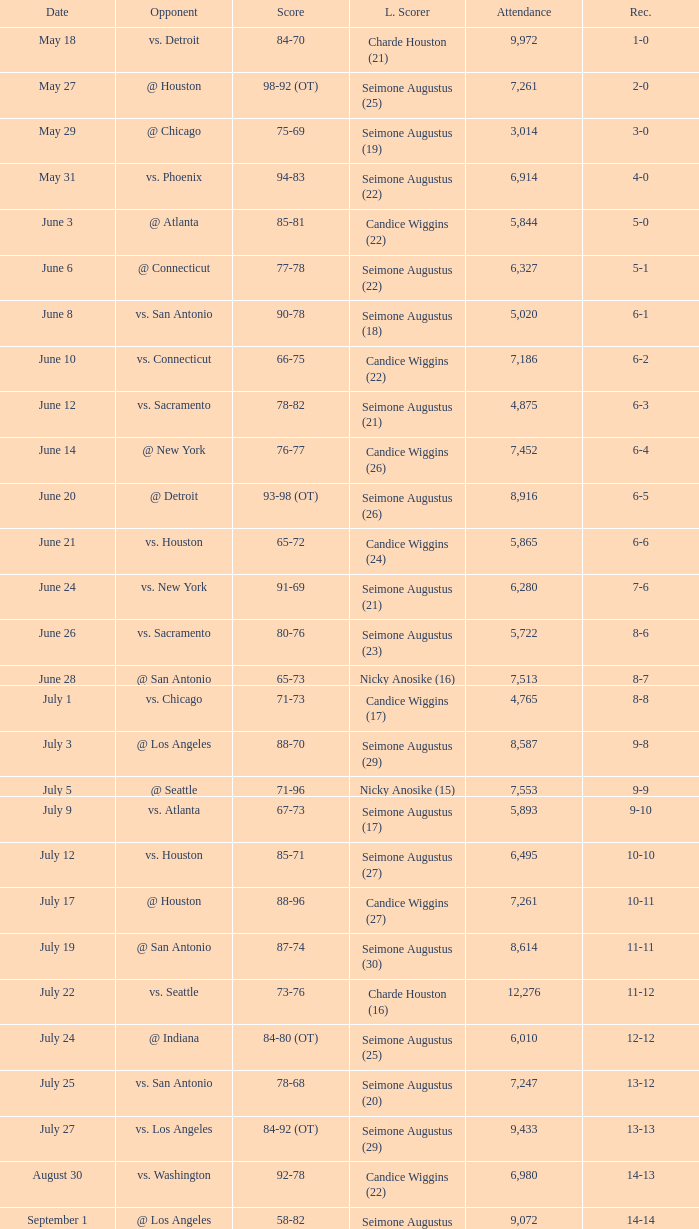Which Leading Scorer has an Opponent of @ seattle, and a Record of 14-16? Seimone Augustus (26). 